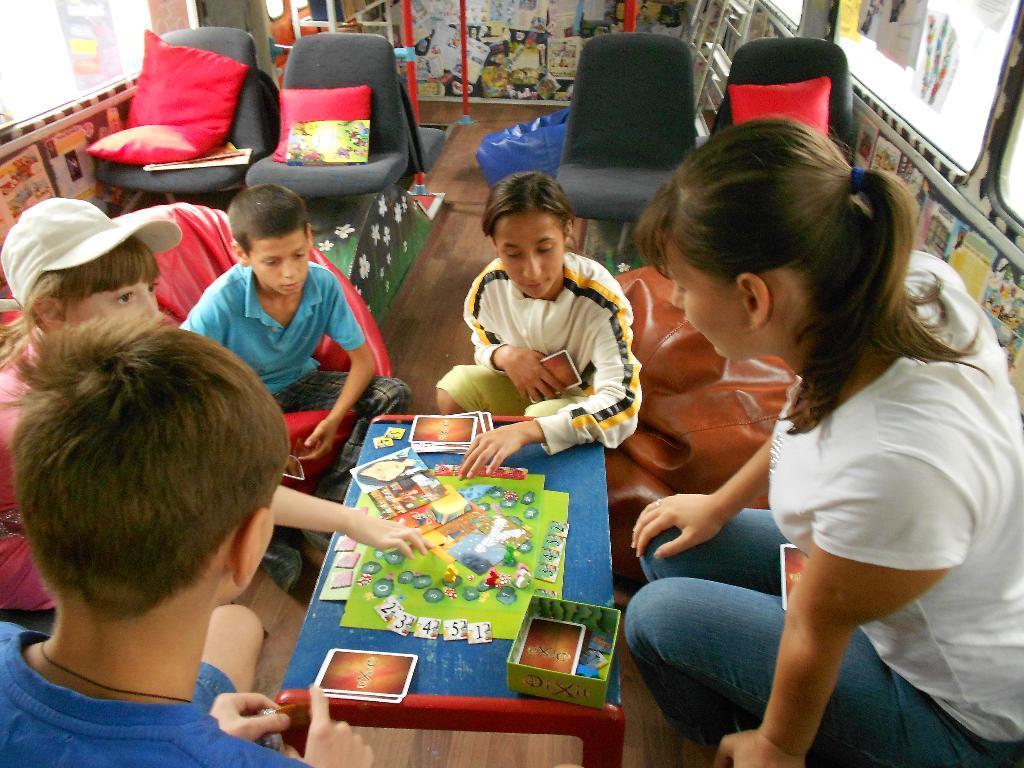Describe this image in one or two sentences. In this image I can see group of people sitting, the person in front is wearing white shirt, blue pant. I can also see few cards on the table and the table is in blue color. Background I can see few seats, pillows in red color and I can also see few windows. 